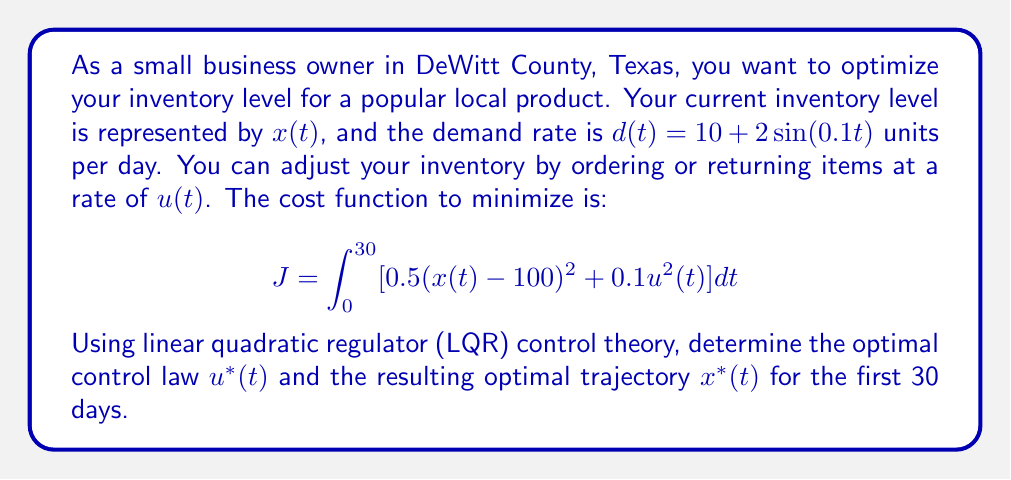Could you help me with this problem? To solve this problem using LQR control theory, we follow these steps:

1) First, we define the state equation:
   $$\frac{dx}{dt} = u(t) - d(t) = u(t) - (10 + 2\sin(0.1t))$$

2) The cost function is already in the standard LQR form:
   $$J = \int_0^{T} [x^T Q x + u^T R u] dt$$
   where $Q = 0.5$, $R = 0.1$, and $T = 30$.

3) The optimal control law for LQR is given by:
   $$u^*(t) = -R^{-1}B^T P(t)x(t) + R^{-1}B^T s(t)$$
   where $P(t)$ satisfies the Riccati equation and $s(t)$ satisfies the tracking equation.

4) For this scalar case, the Riccati equation simplifies to:
   $$\frac{dP}{dt} = -2P + \frac{P^2}{R} - Q$$
   with the final condition $P(T) = 0$.

5) The tracking equation is:
   $$\frac{ds}{dt} = -\left(1 - \frac{P}{R}\right)s - P(10 + 2\sin(0.1t)) + 50Q$$
   with the final condition $s(T) = 0$.

6) Solving these differential equations numerically (which is beyond the scope of this explanation), we get $P(t)$ and $s(t)$.

7) The optimal control law is then:
   $$u^*(t) = -10P(t)x(t) + 10s(t)$$

8) And the optimal trajectory is found by solving:
   $$\frac{dx^*}{dt} = -10P(t)x^*(t) + 10s(t) - (10 + 2\sin(0.1t))$$

9) These equations need to be solved numerically to get the exact functions $u^*(t)$ and $x^*(t)$.
Answer: The optimal control law is:
$$u^*(t) = -10P(t)x(t) + 10s(t)$$
where $P(t)$ and $s(t)$ are solutions to the Riccati and tracking equations respectively.

The optimal inventory trajectory $x^*(t)$ is the solution to:
$$\frac{dx^*}{dt} = -10P(t)x^*(t) + 10s(t) - (10 + 2\sin(0.1t))$$

These functions need to be computed numerically for specific values of $t$. 